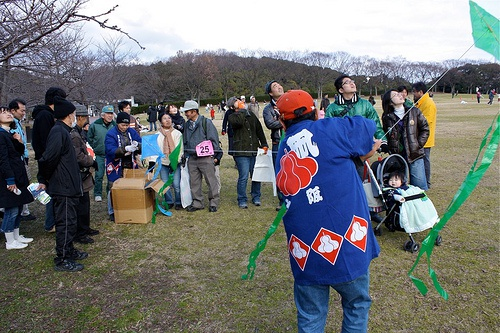Describe the objects in this image and their specific colors. I can see people in darkgray, navy, blue, darkblue, and lavender tones, people in darkgray, black, gray, and navy tones, people in darkgray, gray, black, and darkblue tones, people in darkgray, black, gray, and navy tones, and people in darkgray, black, navy, gray, and blue tones in this image. 